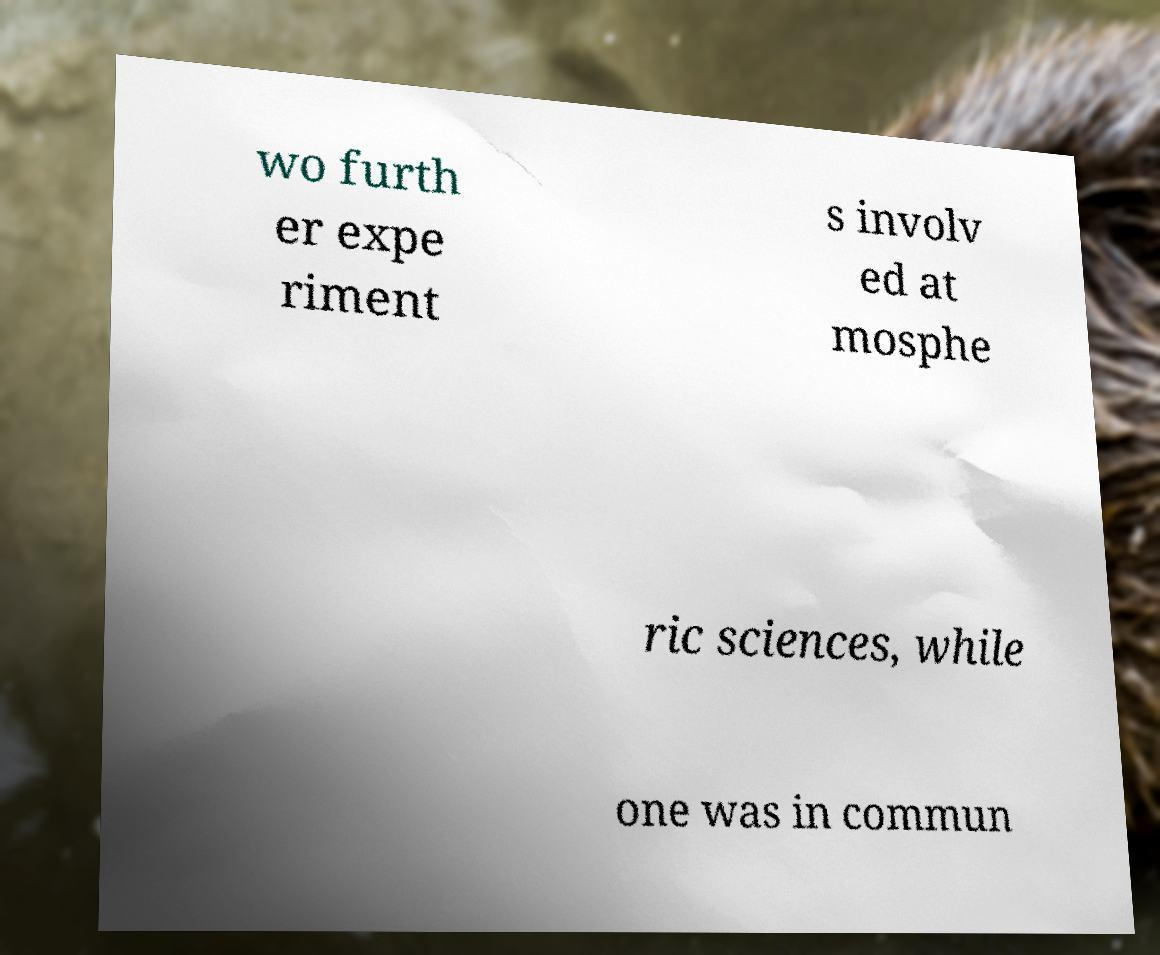There's text embedded in this image that I need extracted. Can you transcribe it verbatim? wo furth er expe riment s involv ed at mosphe ric sciences, while one was in commun 